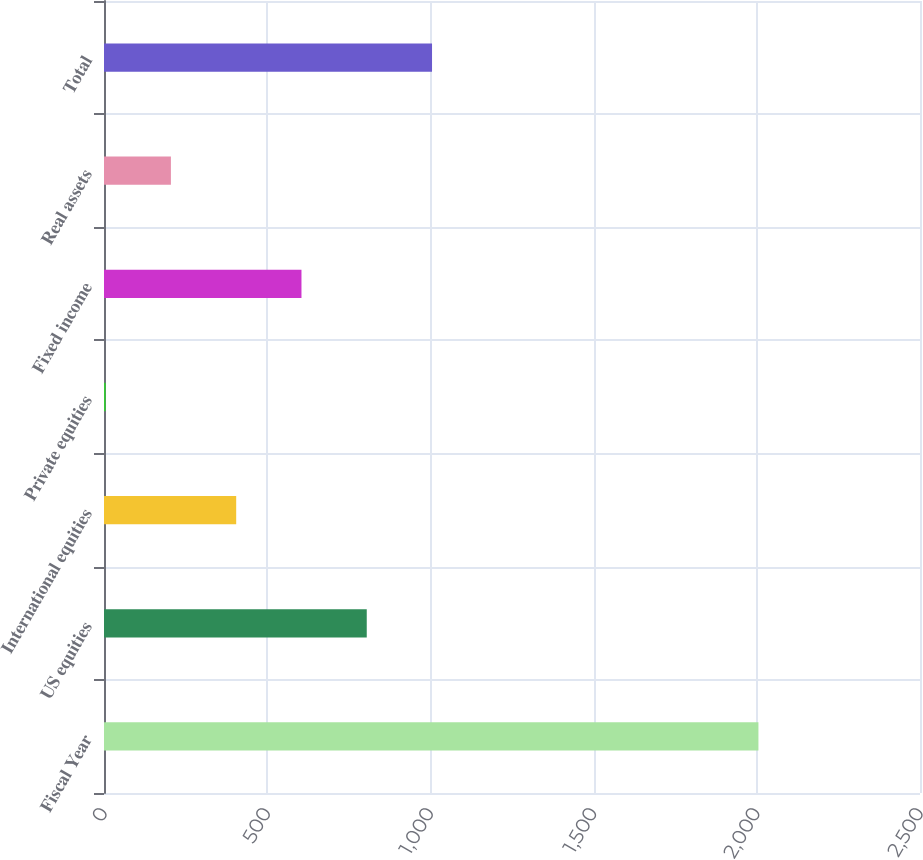Convert chart to OTSL. <chart><loc_0><loc_0><loc_500><loc_500><bar_chart><fcel>Fiscal Year<fcel>US equities<fcel>International equities<fcel>Private equities<fcel>Fixed income<fcel>Real assets<fcel>Total<nl><fcel>2005<fcel>805<fcel>405<fcel>5<fcel>605<fcel>205<fcel>1005<nl></chart> 